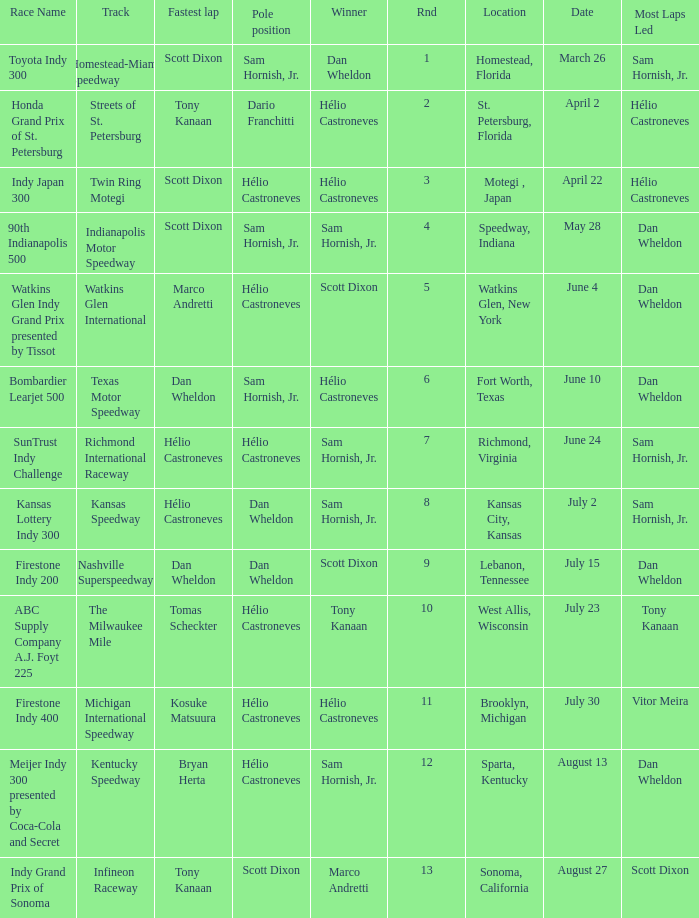How many times is the location is homestead, florida? 1.0. 